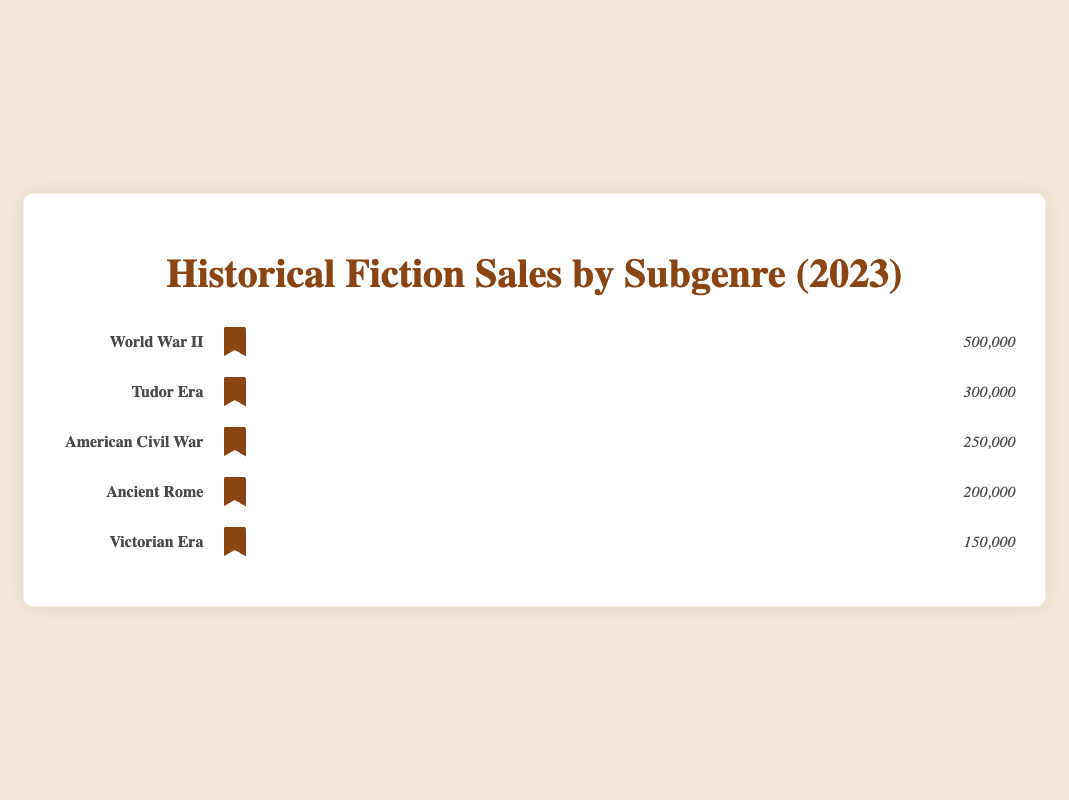What is the subgenre with the highest book sales? The figure visually displays book sales for various subgenres within historical fiction. The subgenre with the longest row of icons (representing books sold) is "World War II," indicating the highest sales.
Answer: World War II How many books were sold in the Tudor Era subgenre? The figure shows a row for the Tudor Era with a label and a count at the end, indicating 300,000 books sold.
Answer: 300,000 Which subgenre has the least book sales? By comparing the lengths of the rows of icons for each subgenre, the row for the Victorian Era is the shortest, indicating it has the least book sales.
Answer: Victorian Era What are the total book sales for all subgenres combined? Sum the number of books sold for each subgenre: 500,000 (World War II) + 300,000 (Tudor Era) + 250,000 (American Civil War) + 200,000 (Ancient Rome) + 150,000 (Victorian Era). The total is 1,400,000 books sold.
Answer: 1,400,000 How many more books were sold in the World War II subgenre compared to the Ancient Rome subgenre? Subtract the number of books sold in Ancient Rome (200,000) from the number sold in World War II (500,000): 500,000 - 200,000 = 300,000.
Answer: 300,000 What percentage of total sales does the American Civil War subgenre represent? First, calculate the total sales (1,400,000). Next, find the ratio of American Civil War sales to the total, and multiply by 100: (250,000 / 1,400,000) * 100 = ~17.86%.
Answer: ~17.86% If the sales for the Victorian Era subgenre doubled, what would be the new total sales? Current sales for the Victorian Era are 150,000. If doubled, it becomes 150,000 * 2 = 300,000. Add this to the existing total sales (1,400,000), then subtract the old Victorian Era sales: 1,400,000 + 150,000 = 1,550,000.
Answer: 1,550,000 Which two subgenres have sales that, when combined, exceed 700,000 books? Combine different subgenre sales to find a pair: 500,000 (World War II) + 300,000 (Tudor Era) = 800,000; this pair exceeds 700,000.
Answer: World War II and Tudor Era 